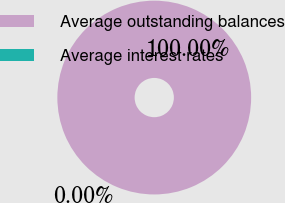Convert chart. <chart><loc_0><loc_0><loc_500><loc_500><pie_chart><fcel>Average outstanding balances<fcel>Average interest rates<nl><fcel>100.0%<fcel>0.0%<nl></chart> 